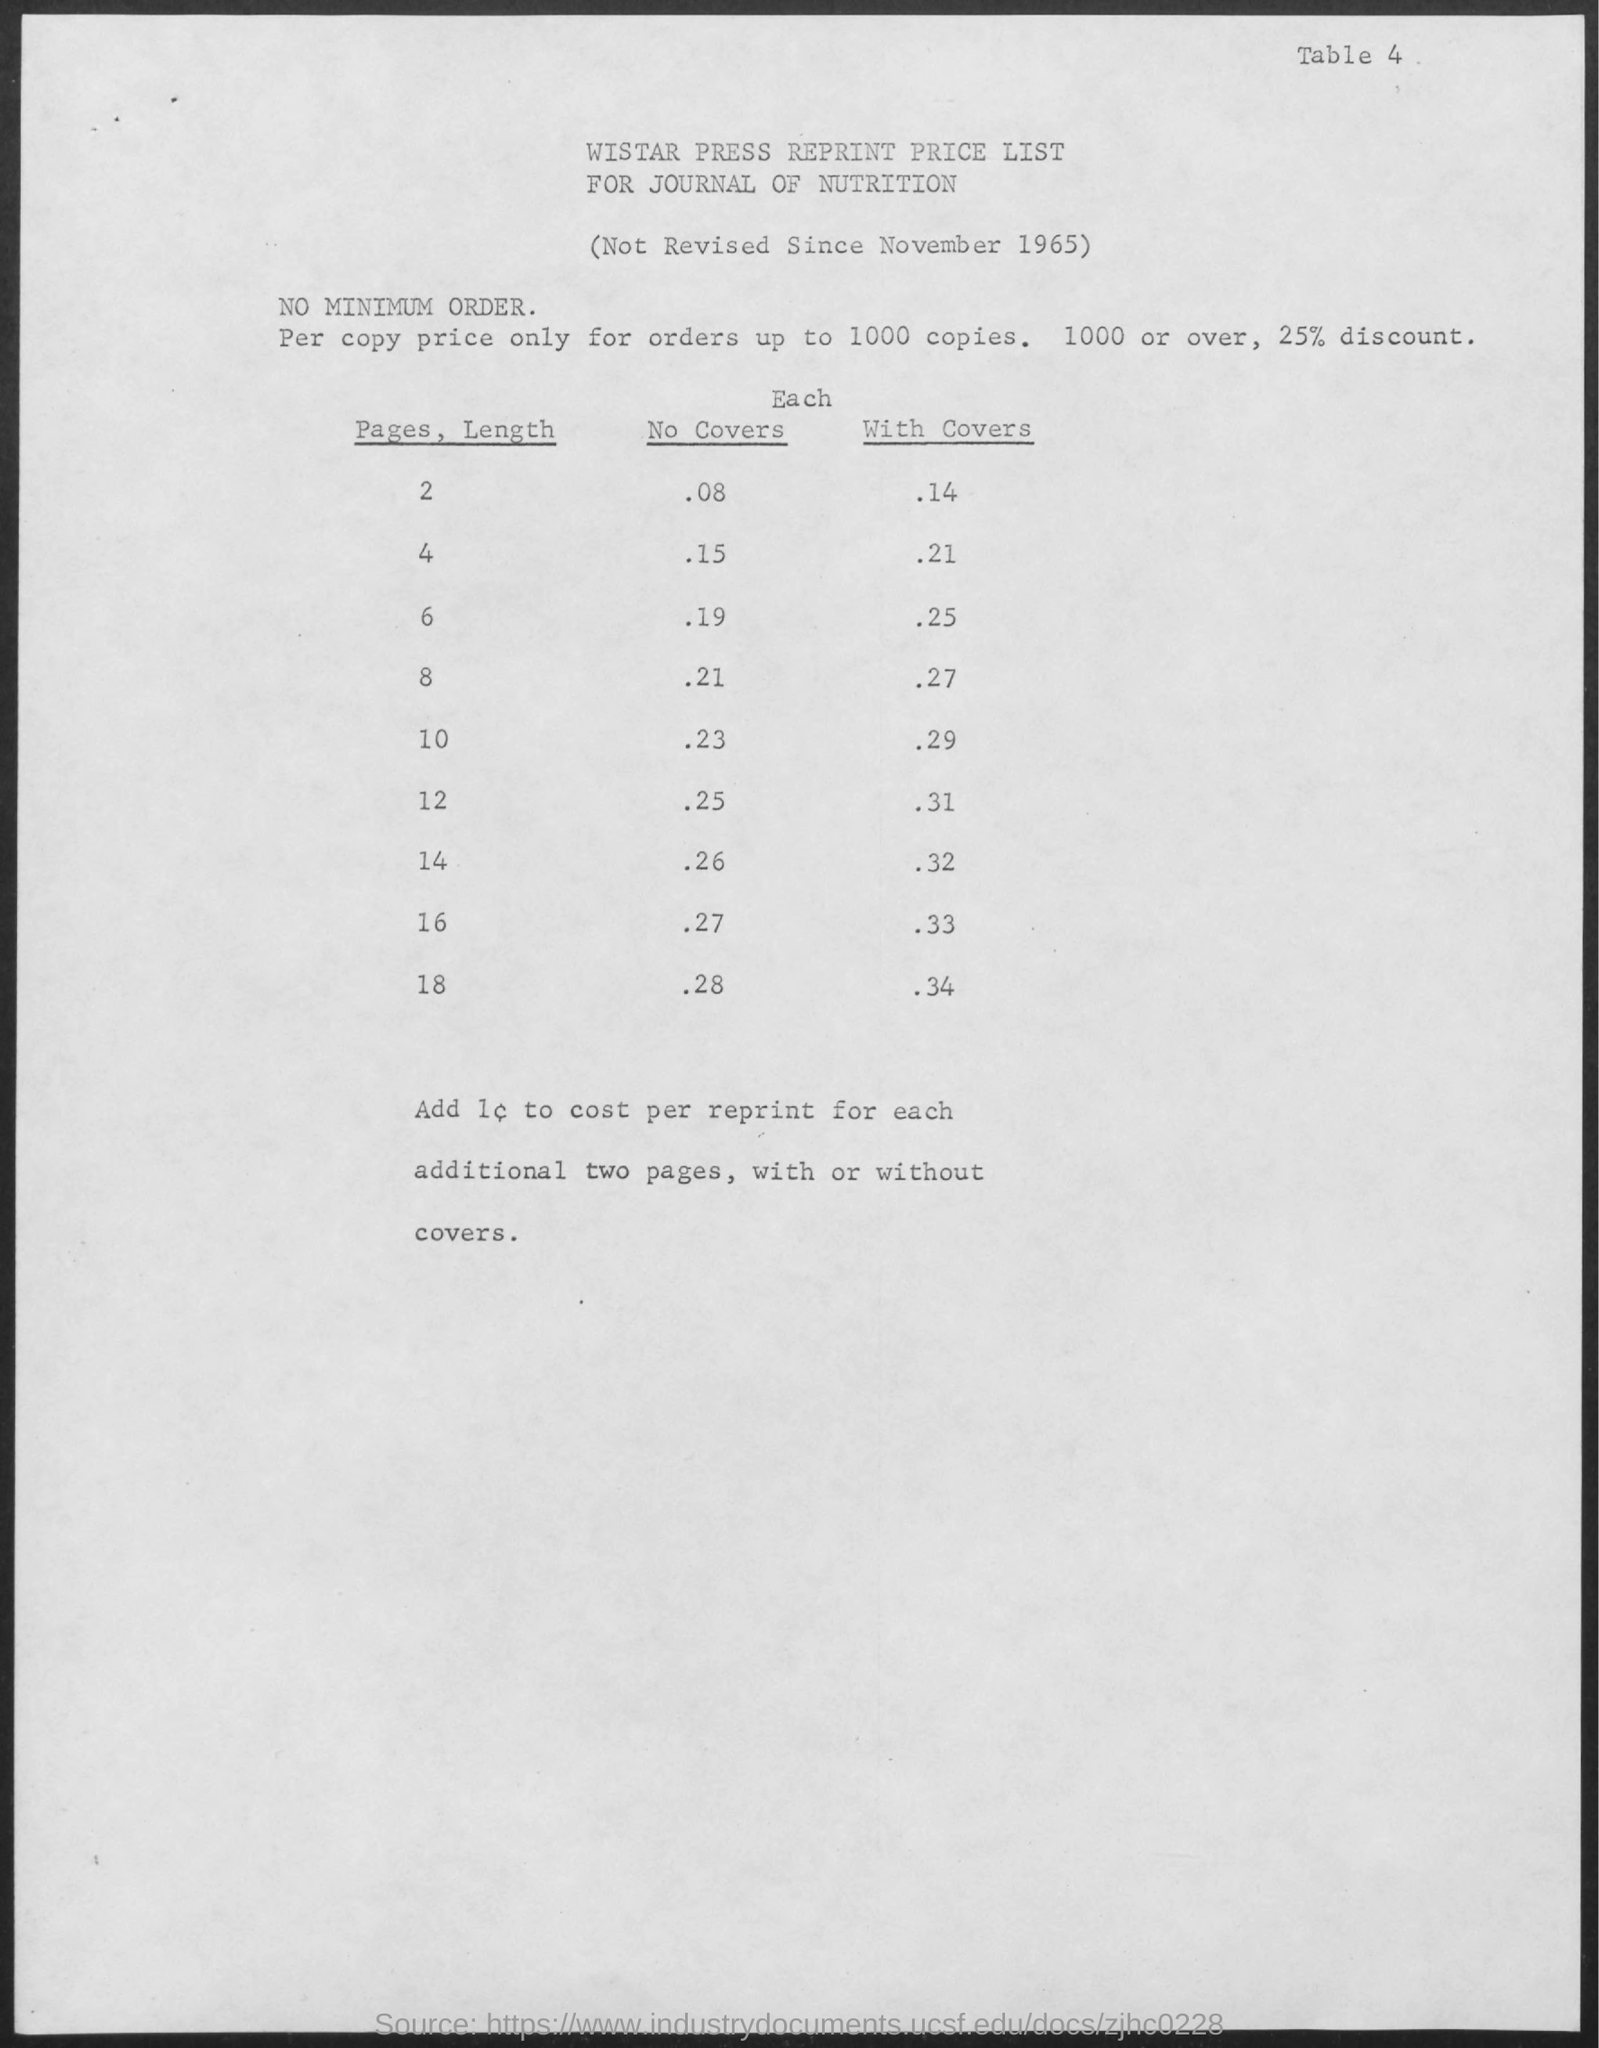What is the title of the document?
Offer a very short reply. Wistar press reprint price list for journal of nutrition. 